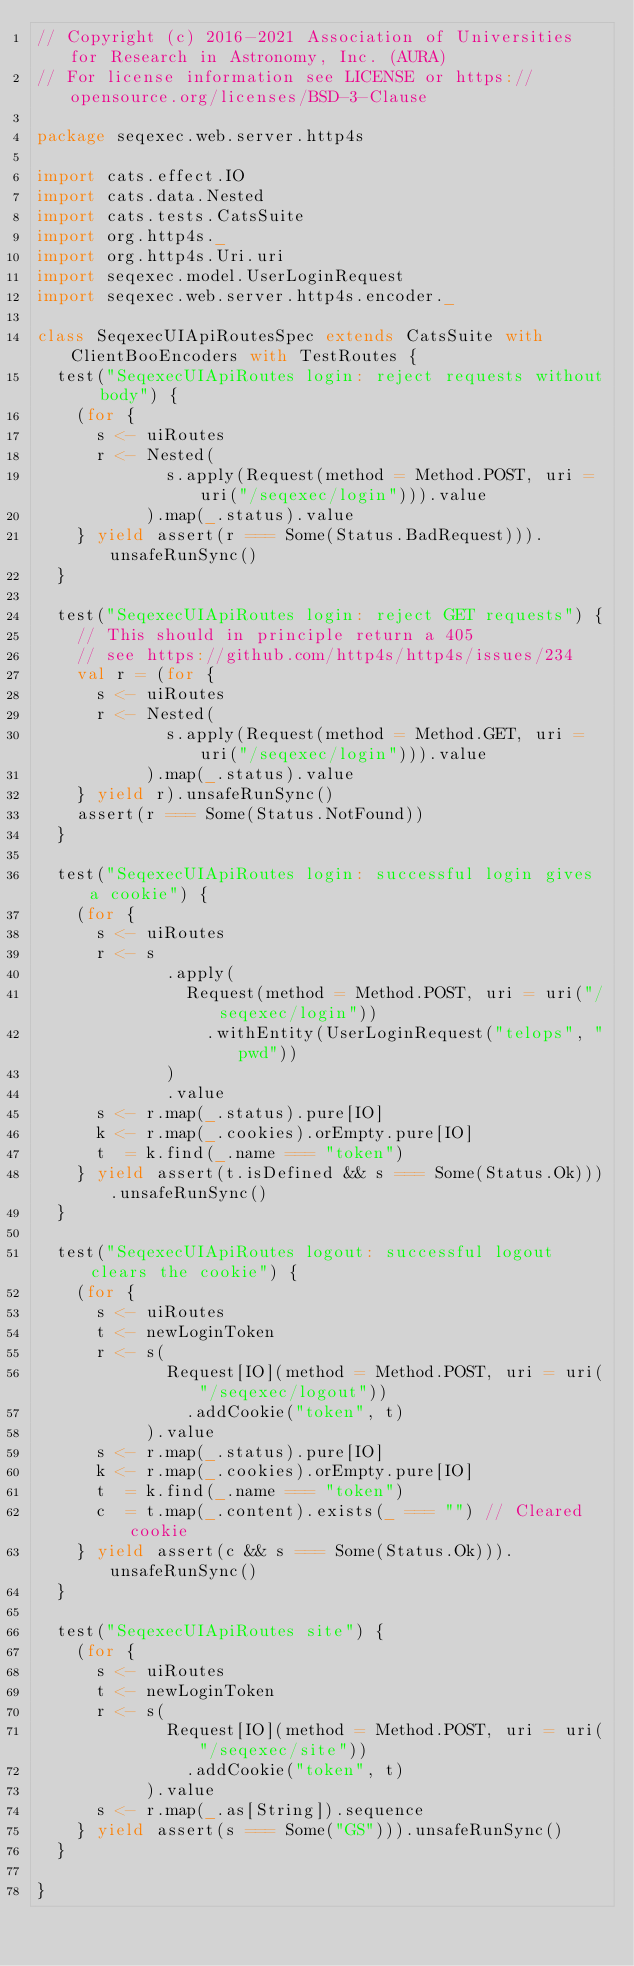Convert code to text. <code><loc_0><loc_0><loc_500><loc_500><_Scala_>// Copyright (c) 2016-2021 Association of Universities for Research in Astronomy, Inc. (AURA)
// For license information see LICENSE or https://opensource.org/licenses/BSD-3-Clause

package seqexec.web.server.http4s

import cats.effect.IO
import cats.data.Nested
import cats.tests.CatsSuite
import org.http4s._
import org.http4s.Uri.uri
import seqexec.model.UserLoginRequest
import seqexec.web.server.http4s.encoder._

class SeqexecUIApiRoutesSpec extends CatsSuite with ClientBooEncoders with TestRoutes {
  test("SeqexecUIApiRoutes login: reject requests without body") {
    (for {
      s <- uiRoutes
      r <- Nested(
             s.apply(Request(method = Method.POST, uri = uri("/seqexec/login"))).value
           ).map(_.status).value
    } yield assert(r === Some(Status.BadRequest))).unsafeRunSync()
  }

  test("SeqexecUIApiRoutes login: reject GET requests") {
    // This should in principle return a 405
    // see https://github.com/http4s/http4s/issues/234
    val r = (for {
      s <- uiRoutes
      r <- Nested(
             s.apply(Request(method = Method.GET, uri = uri("/seqexec/login"))).value
           ).map(_.status).value
    } yield r).unsafeRunSync()
    assert(r === Some(Status.NotFound))
  }

  test("SeqexecUIApiRoutes login: successful login gives a cookie") {
    (for {
      s <- uiRoutes
      r <- s
             .apply(
               Request(method = Method.POST, uri = uri("/seqexec/login"))
                 .withEntity(UserLoginRequest("telops", "pwd"))
             )
             .value
      s <- r.map(_.status).pure[IO]
      k <- r.map(_.cookies).orEmpty.pure[IO]
      t  = k.find(_.name === "token")
    } yield assert(t.isDefined && s === Some(Status.Ok))).unsafeRunSync()
  }

  test("SeqexecUIApiRoutes logout: successful logout clears the cookie") {
    (for {
      s <- uiRoutes
      t <- newLoginToken
      r <- s(
             Request[IO](method = Method.POST, uri = uri("/seqexec/logout"))
               .addCookie("token", t)
           ).value
      s <- r.map(_.status).pure[IO]
      k <- r.map(_.cookies).orEmpty.pure[IO]
      t  = k.find(_.name === "token")
      c  = t.map(_.content).exists(_ === "") // Cleared cookie
    } yield assert(c && s === Some(Status.Ok))).unsafeRunSync()
  }

  test("SeqexecUIApiRoutes site") {
    (for {
      s <- uiRoutes
      t <- newLoginToken
      r <- s(
             Request[IO](method = Method.POST, uri = uri("/seqexec/site"))
               .addCookie("token", t)
           ).value
      s <- r.map(_.as[String]).sequence
    } yield assert(s === Some("GS"))).unsafeRunSync()
  }

}
</code> 